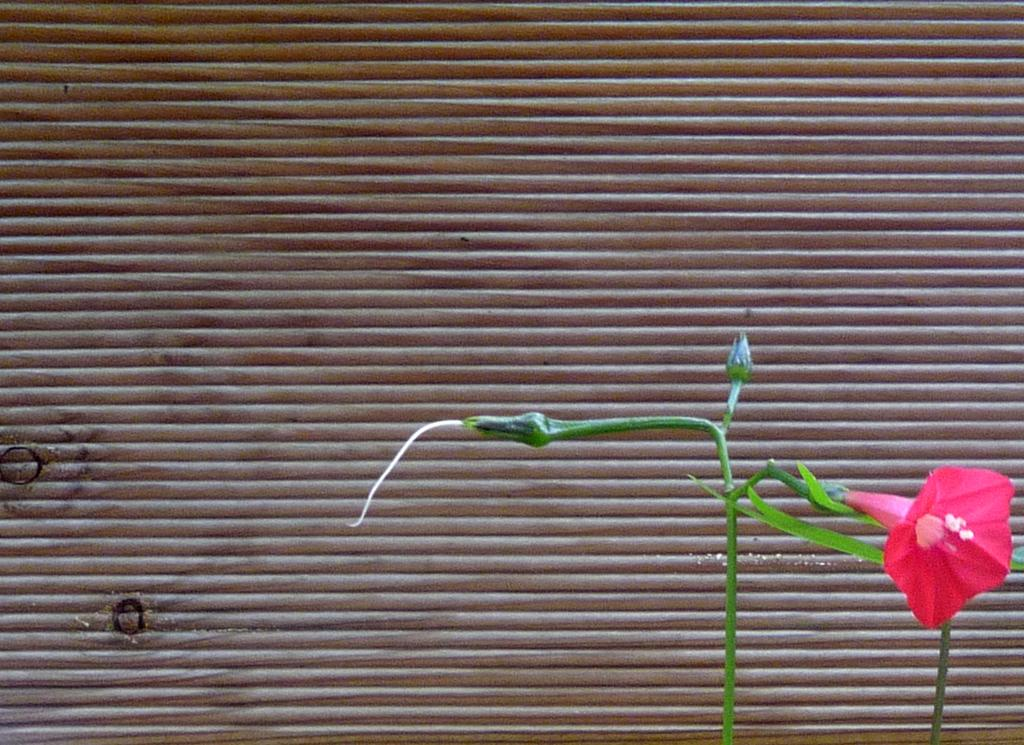What is present in the image related to vegetation? There is a plant in the image. What can be observed about the plant's flower? The plant has a flower, and it is pink. Are there any unopened parts on the plant? Yes, there are buds on the plant. What can be seen in the background of the image? There are blinds in the background of the image. What type of pies are being served at the feast in the image? There is no feast or pies present in the image; it features a plant with a pink flower and buds. Can you describe the snail's shell color in the image? There is no snail present in the image. 